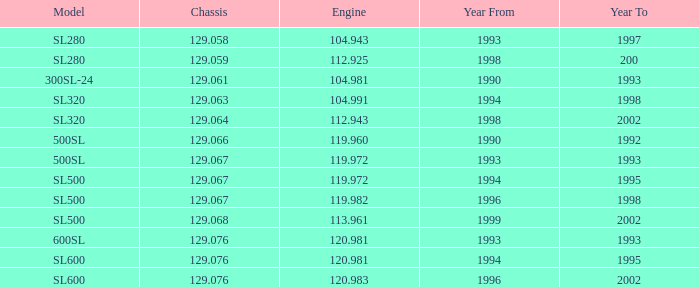Which engine features a model sl500 and has a chassis size smaller than 129.067? None. 